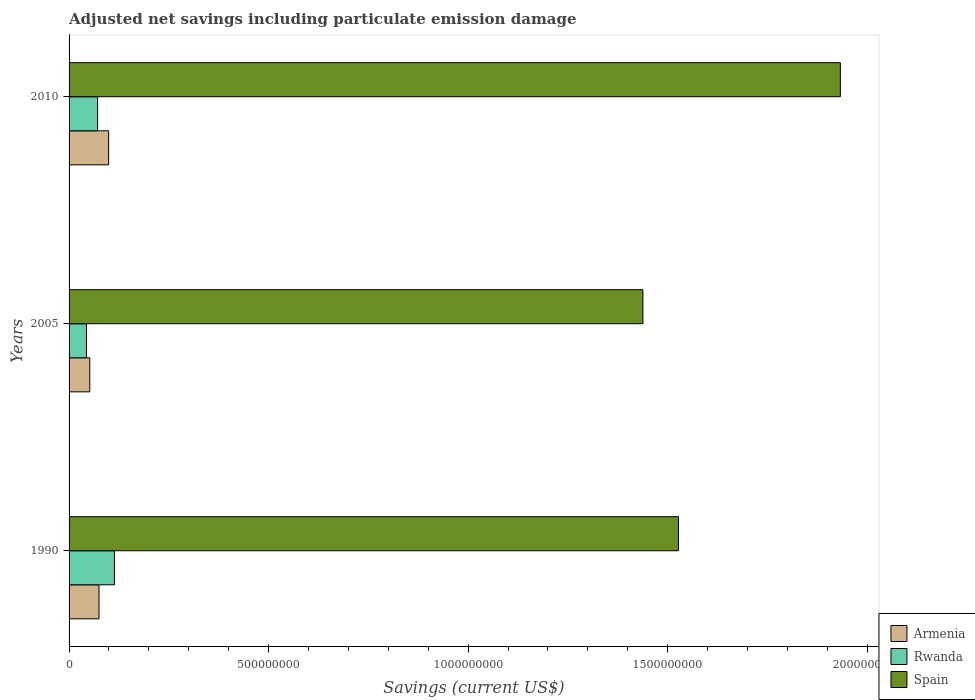How many groups of bars are there?
Offer a terse response. 3. Are the number of bars per tick equal to the number of legend labels?
Your answer should be compact. Yes. Are the number of bars on each tick of the Y-axis equal?
Your response must be concise. Yes. What is the net savings in Rwanda in 2010?
Your response must be concise. 7.14e+07. Across all years, what is the maximum net savings in Armenia?
Make the answer very short. 9.91e+07. Across all years, what is the minimum net savings in Armenia?
Keep it short and to the point. 5.19e+07. In which year was the net savings in Spain minimum?
Your answer should be very brief. 2005. What is the total net savings in Armenia in the graph?
Your answer should be very brief. 2.26e+08. What is the difference between the net savings in Spain in 1990 and that in 2005?
Give a very brief answer. 8.92e+07. What is the difference between the net savings in Armenia in 2010 and the net savings in Spain in 2005?
Ensure brevity in your answer.  -1.34e+09. What is the average net savings in Rwanda per year?
Offer a very short reply. 7.63e+07. In the year 1990, what is the difference between the net savings in Armenia and net savings in Spain?
Make the answer very short. -1.45e+09. What is the ratio of the net savings in Spain in 1990 to that in 2010?
Give a very brief answer. 0.79. What is the difference between the highest and the second highest net savings in Spain?
Offer a very short reply. 4.06e+08. What is the difference between the highest and the lowest net savings in Rwanda?
Your response must be concise. 7.01e+07. In how many years, is the net savings in Spain greater than the average net savings in Spain taken over all years?
Offer a terse response. 1. What does the 2nd bar from the top in 2010 represents?
Keep it short and to the point. Rwanda. What does the 3rd bar from the bottom in 1990 represents?
Offer a terse response. Spain. Is it the case that in every year, the sum of the net savings in Spain and net savings in Rwanda is greater than the net savings in Armenia?
Give a very brief answer. Yes. How many bars are there?
Your response must be concise. 9. How many years are there in the graph?
Keep it short and to the point. 3. What is the difference between two consecutive major ticks on the X-axis?
Your answer should be compact. 5.00e+08. Does the graph contain grids?
Make the answer very short. No. Where does the legend appear in the graph?
Make the answer very short. Bottom right. How many legend labels are there?
Offer a very short reply. 3. How are the legend labels stacked?
Provide a short and direct response. Vertical. What is the title of the graph?
Ensure brevity in your answer.  Adjusted net savings including particulate emission damage. Does "Cyprus" appear as one of the legend labels in the graph?
Ensure brevity in your answer.  No. What is the label or title of the X-axis?
Offer a very short reply. Savings (current US$). What is the Savings (current US$) in Armenia in 1990?
Offer a terse response. 7.50e+07. What is the Savings (current US$) of Rwanda in 1990?
Your response must be concise. 1.14e+08. What is the Savings (current US$) in Spain in 1990?
Offer a very short reply. 1.53e+09. What is the Savings (current US$) in Armenia in 2005?
Keep it short and to the point. 5.19e+07. What is the Savings (current US$) of Rwanda in 2005?
Your response must be concise. 4.36e+07. What is the Savings (current US$) in Spain in 2005?
Your answer should be very brief. 1.44e+09. What is the Savings (current US$) in Armenia in 2010?
Provide a short and direct response. 9.91e+07. What is the Savings (current US$) of Rwanda in 2010?
Make the answer very short. 7.14e+07. What is the Savings (current US$) in Spain in 2010?
Make the answer very short. 1.93e+09. Across all years, what is the maximum Savings (current US$) in Armenia?
Keep it short and to the point. 9.91e+07. Across all years, what is the maximum Savings (current US$) in Rwanda?
Ensure brevity in your answer.  1.14e+08. Across all years, what is the maximum Savings (current US$) of Spain?
Offer a very short reply. 1.93e+09. Across all years, what is the minimum Savings (current US$) of Armenia?
Your response must be concise. 5.19e+07. Across all years, what is the minimum Savings (current US$) of Rwanda?
Keep it short and to the point. 4.36e+07. Across all years, what is the minimum Savings (current US$) of Spain?
Give a very brief answer. 1.44e+09. What is the total Savings (current US$) of Armenia in the graph?
Offer a terse response. 2.26e+08. What is the total Savings (current US$) of Rwanda in the graph?
Your response must be concise. 2.29e+08. What is the total Savings (current US$) in Spain in the graph?
Provide a succinct answer. 4.90e+09. What is the difference between the Savings (current US$) in Armenia in 1990 and that in 2005?
Make the answer very short. 2.32e+07. What is the difference between the Savings (current US$) in Rwanda in 1990 and that in 2005?
Give a very brief answer. 7.01e+07. What is the difference between the Savings (current US$) of Spain in 1990 and that in 2005?
Your answer should be compact. 8.92e+07. What is the difference between the Savings (current US$) of Armenia in 1990 and that in 2010?
Give a very brief answer. -2.41e+07. What is the difference between the Savings (current US$) of Rwanda in 1990 and that in 2010?
Offer a terse response. 4.23e+07. What is the difference between the Savings (current US$) of Spain in 1990 and that in 2010?
Give a very brief answer. -4.06e+08. What is the difference between the Savings (current US$) of Armenia in 2005 and that in 2010?
Keep it short and to the point. -4.72e+07. What is the difference between the Savings (current US$) of Rwanda in 2005 and that in 2010?
Ensure brevity in your answer.  -2.78e+07. What is the difference between the Savings (current US$) in Spain in 2005 and that in 2010?
Keep it short and to the point. -4.95e+08. What is the difference between the Savings (current US$) in Armenia in 1990 and the Savings (current US$) in Rwanda in 2005?
Your response must be concise. 3.14e+07. What is the difference between the Savings (current US$) of Armenia in 1990 and the Savings (current US$) of Spain in 2005?
Offer a very short reply. -1.36e+09. What is the difference between the Savings (current US$) of Rwanda in 1990 and the Savings (current US$) of Spain in 2005?
Your response must be concise. -1.32e+09. What is the difference between the Savings (current US$) in Armenia in 1990 and the Savings (current US$) in Rwanda in 2010?
Keep it short and to the point. 3.61e+06. What is the difference between the Savings (current US$) in Armenia in 1990 and the Savings (current US$) in Spain in 2010?
Offer a terse response. -1.86e+09. What is the difference between the Savings (current US$) in Rwanda in 1990 and the Savings (current US$) in Spain in 2010?
Your answer should be very brief. -1.82e+09. What is the difference between the Savings (current US$) in Armenia in 2005 and the Savings (current US$) in Rwanda in 2010?
Your answer should be compact. -1.95e+07. What is the difference between the Savings (current US$) of Armenia in 2005 and the Savings (current US$) of Spain in 2010?
Ensure brevity in your answer.  -1.88e+09. What is the difference between the Savings (current US$) of Rwanda in 2005 and the Savings (current US$) of Spain in 2010?
Offer a very short reply. -1.89e+09. What is the average Savings (current US$) of Armenia per year?
Ensure brevity in your answer.  7.53e+07. What is the average Savings (current US$) in Rwanda per year?
Provide a short and direct response. 7.63e+07. What is the average Savings (current US$) of Spain per year?
Ensure brevity in your answer.  1.63e+09. In the year 1990, what is the difference between the Savings (current US$) in Armenia and Savings (current US$) in Rwanda?
Your answer should be very brief. -3.87e+07. In the year 1990, what is the difference between the Savings (current US$) in Armenia and Savings (current US$) in Spain?
Ensure brevity in your answer.  -1.45e+09. In the year 1990, what is the difference between the Savings (current US$) in Rwanda and Savings (current US$) in Spain?
Offer a terse response. -1.41e+09. In the year 2005, what is the difference between the Savings (current US$) in Armenia and Savings (current US$) in Rwanda?
Make the answer very short. 8.25e+06. In the year 2005, what is the difference between the Savings (current US$) in Armenia and Savings (current US$) in Spain?
Make the answer very short. -1.39e+09. In the year 2005, what is the difference between the Savings (current US$) of Rwanda and Savings (current US$) of Spain?
Ensure brevity in your answer.  -1.39e+09. In the year 2010, what is the difference between the Savings (current US$) in Armenia and Savings (current US$) in Rwanda?
Your response must be concise. 2.77e+07. In the year 2010, what is the difference between the Savings (current US$) in Armenia and Savings (current US$) in Spain?
Your answer should be compact. -1.83e+09. In the year 2010, what is the difference between the Savings (current US$) in Rwanda and Savings (current US$) in Spain?
Ensure brevity in your answer.  -1.86e+09. What is the ratio of the Savings (current US$) of Armenia in 1990 to that in 2005?
Provide a short and direct response. 1.45. What is the ratio of the Savings (current US$) of Rwanda in 1990 to that in 2005?
Your answer should be compact. 2.61. What is the ratio of the Savings (current US$) in Spain in 1990 to that in 2005?
Make the answer very short. 1.06. What is the ratio of the Savings (current US$) of Armenia in 1990 to that in 2010?
Make the answer very short. 0.76. What is the ratio of the Savings (current US$) in Rwanda in 1990 to that in 2010?
Offer a terse response. 1.59. What is the ratio of the Savings (current US$) of Spain in 1990 to that in 2010?
Your answer should be very brief. 0.79. What is the ratio of the Savings (current US$) of Armenia in 2005 to that in 2010?
Your answer should be very brief. 0.52. What is the ratio of the Savings (current US$) of Rwanda in 2005 to that in 2010?
Give a very brief answer. 0.61. What is the ratio of the Savings (current US$) of Spain in 2005 to that in 2010?
Your response must be concise. 0.74. What is the difference between the highest and the second highest Savings (current US$) of Armenia?
Make the answer very short. 2.41e+07. What is the difference between the highest and the second highest Savings (current US$) in Rwanda?
Your response must be concise. 4.23e+07. What is the difference between the highest and the second highest Savings (current US$) in Spain?
Your response must be concise. 4.06e+08. What is the difference between the highest and the lowest Savings (current US$) in Armenia?
Make the answer very short. 4.72e+07. What is the difference between the highest and the lowest Savings (current US$) of Rwanda?
Make the answer very short. 7.01e+07. What is the difference between the highest and the lowest Savings (current US$) in Spain?
Offer a very short reply. 4.95e+08. 